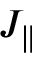<formula> <loc_0><loc_0><loc_500><loc_500>J _ { \| }</formula> 